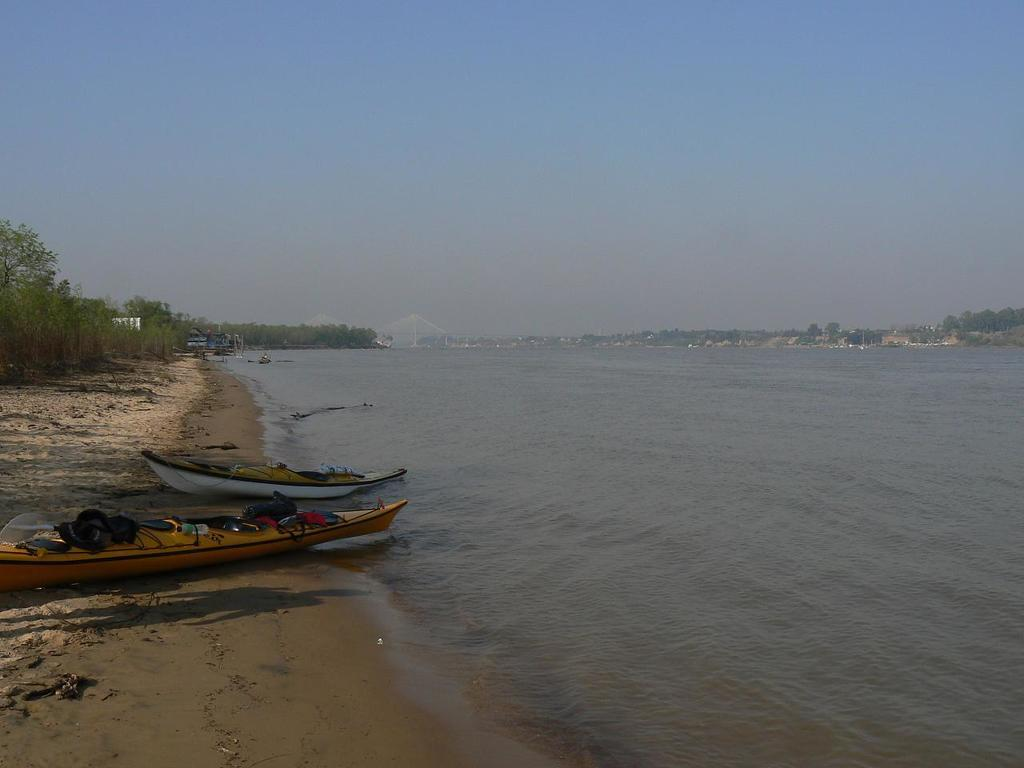How many boats are in the image? There are two boats in the image. What can be seen in the left corner of the image? There are trees in the left corner of the image. What is visible beside the boats? There is water visible beside the boats. What is visible in the background of the image? There are trees in the background of the image. How many plants are in the plantation visible in the image? There is no plantation present in the image. 